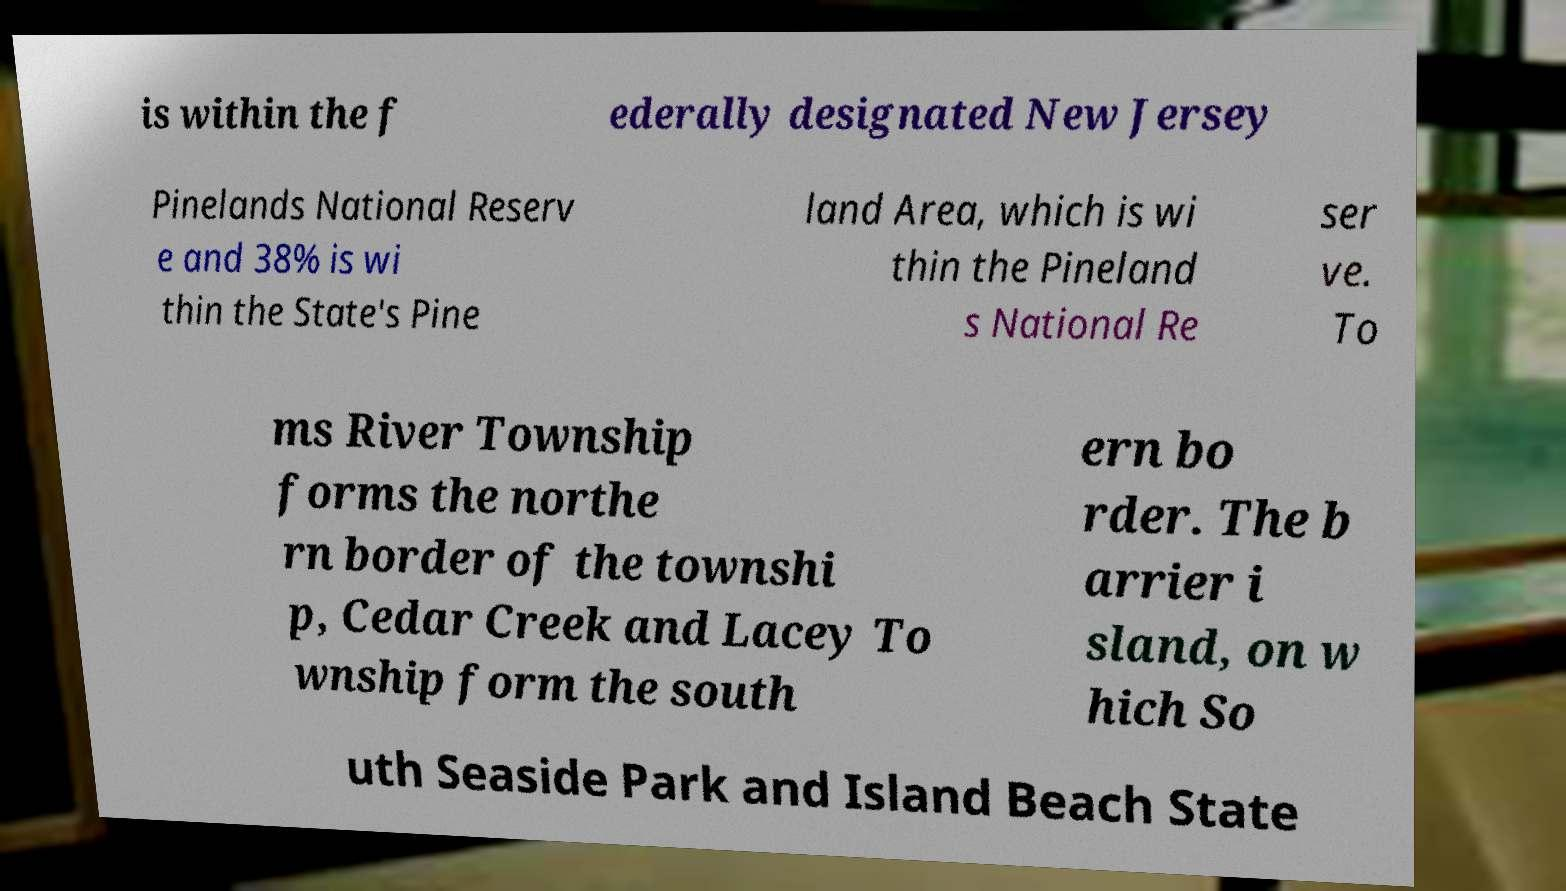Please identify and transcribe the text found in this image. is within the f ederally designated New Jersey Pinelands National Reserv e and 38% is wi thin the State's Pine land Area, which is wi thin the Pineland s National Re ser ve. To ms River Township forms the northe rn border of the townshi p, Cedar Creek and Lacey To wnship form the south ern bo rder. The b arrier i sland, on w hich So uth Seaside Park and Island Beach State 